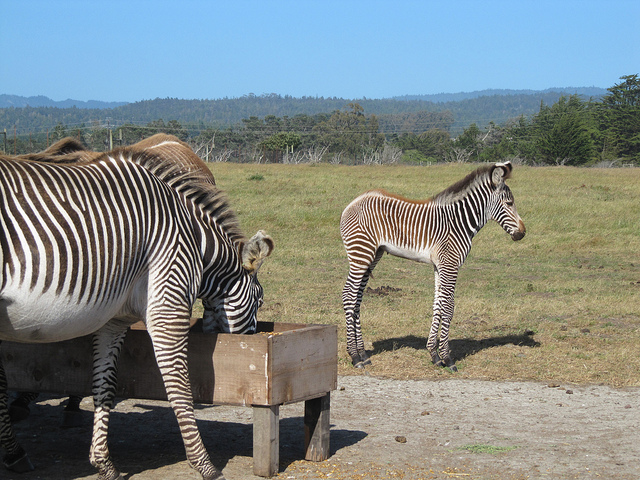<image>Do you think that zebra in front is the baby zebra's mother? I am not sure if the zebra in front is the baby zebra's mother. Do you think that zebra in front is the baby zebra's mother? I don't know if the zebra in front is the baby zebra's mother. It is unclear based on the available information. 